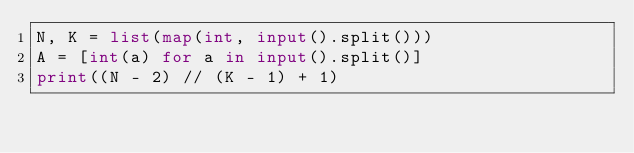<code> <loc_0><loc_0><loc_500><loc_500><_Python_>N, K = list(map(int, input().split()))
A = [int(a) for a in input().split()]
print((N - 2) // (K - 1) + 1)
</code> 